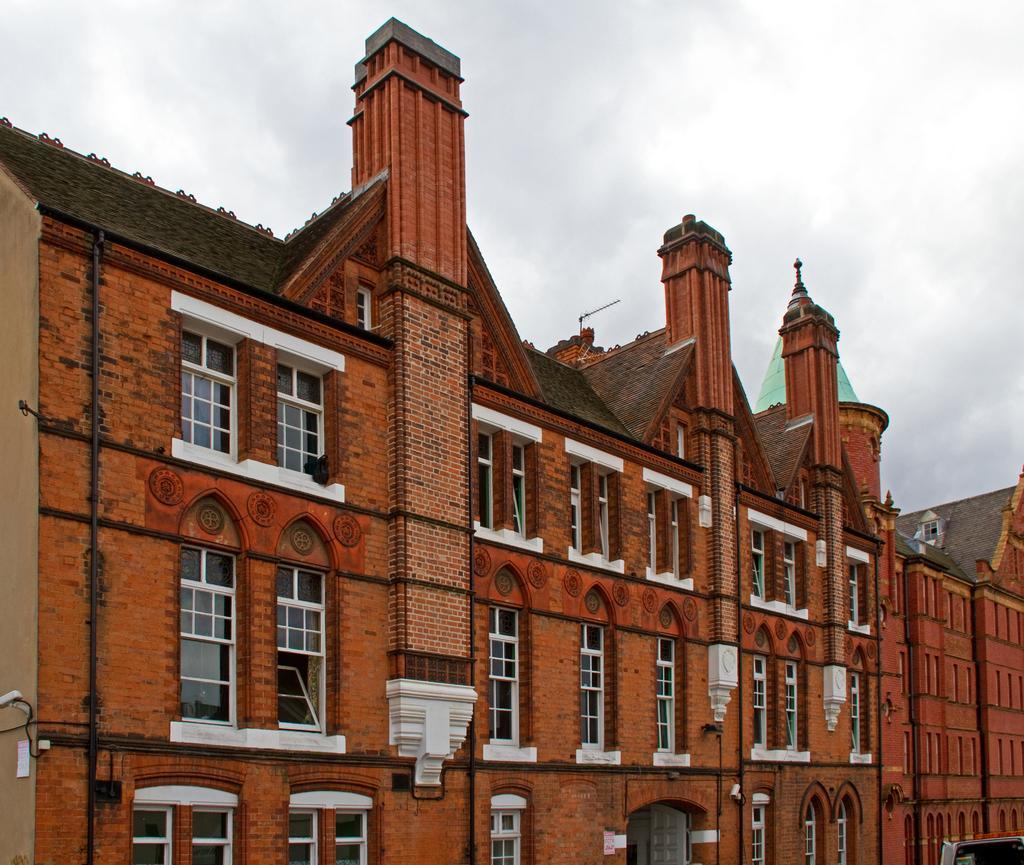Please provide a concise description of this image. In the center of the image there is building with windows. At the top of the image there is sky. 